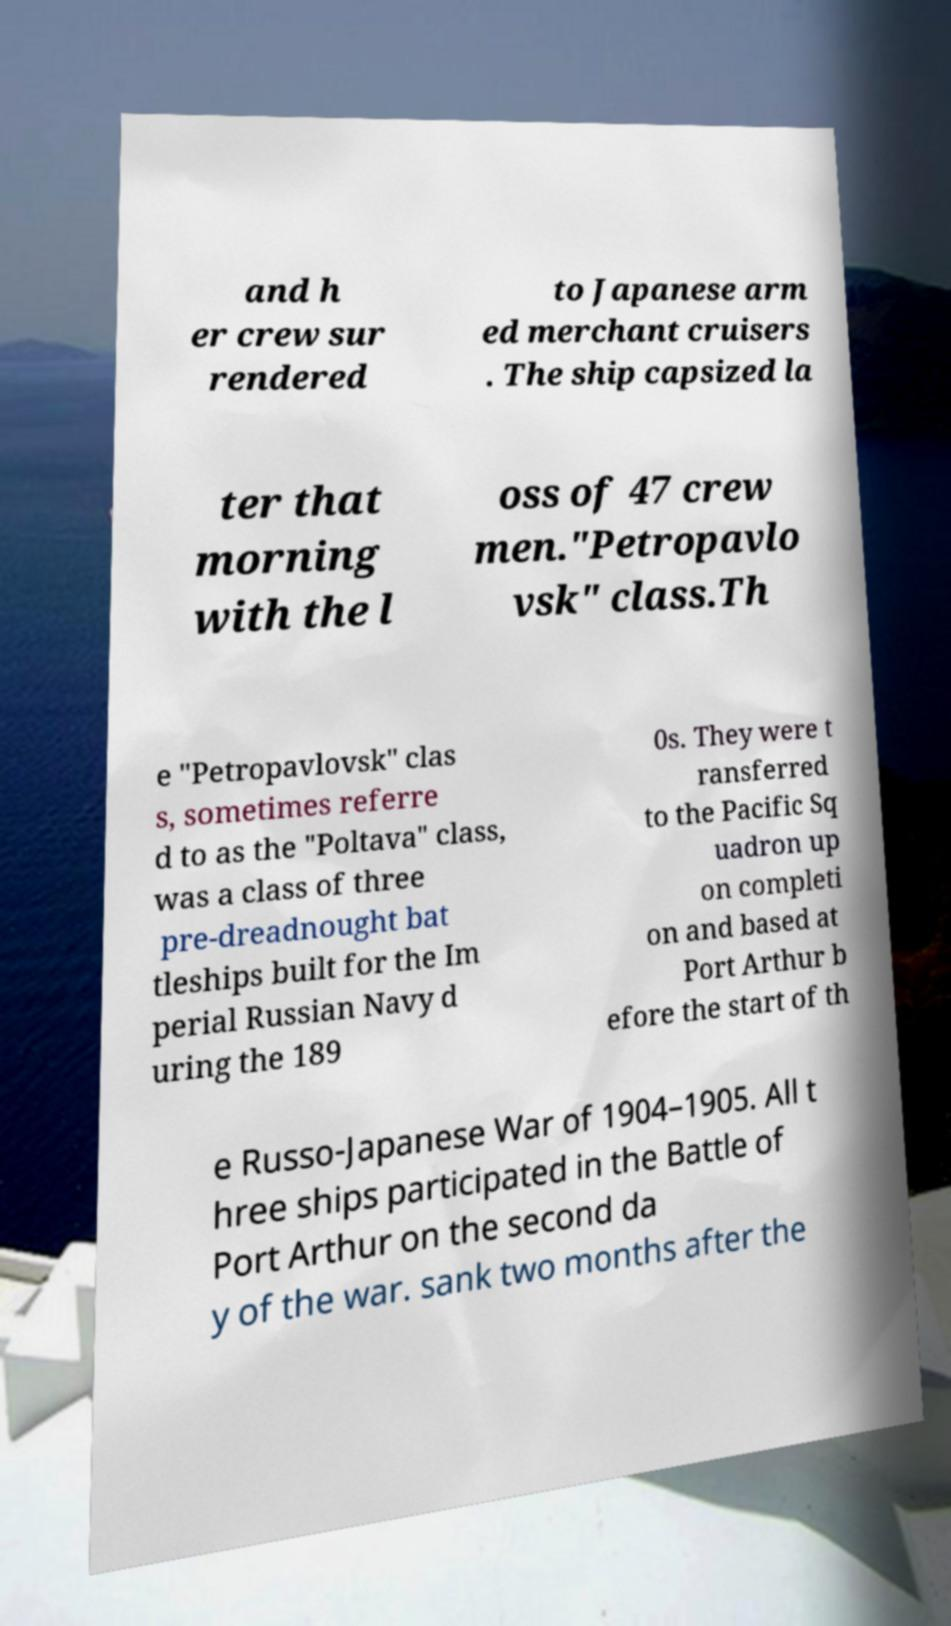Can you accurately transcribe the text from the provided image for me? and h er crew sur rendered to Japanese arm ed merchant cruisers . The ship capsized la ter that morning with the l oss of 47 crew men."Petropavlo vsk" class.Th e "Petropavlovsk" clas s, sometimes referre d to as the "Poltava" class, was a class of three pre-dreadnought bat tleships built for the Im perial Russian Navy d uring the 189 0s. They were t ransferred to the Pacific Sq uadron up on completi on and based at Port Arthur b efore the start of th e Russo-Japanese War of 1904–1905. All t hree ships participated in the Battle of Port Arthur on the second da y of the war. sank two months after the 